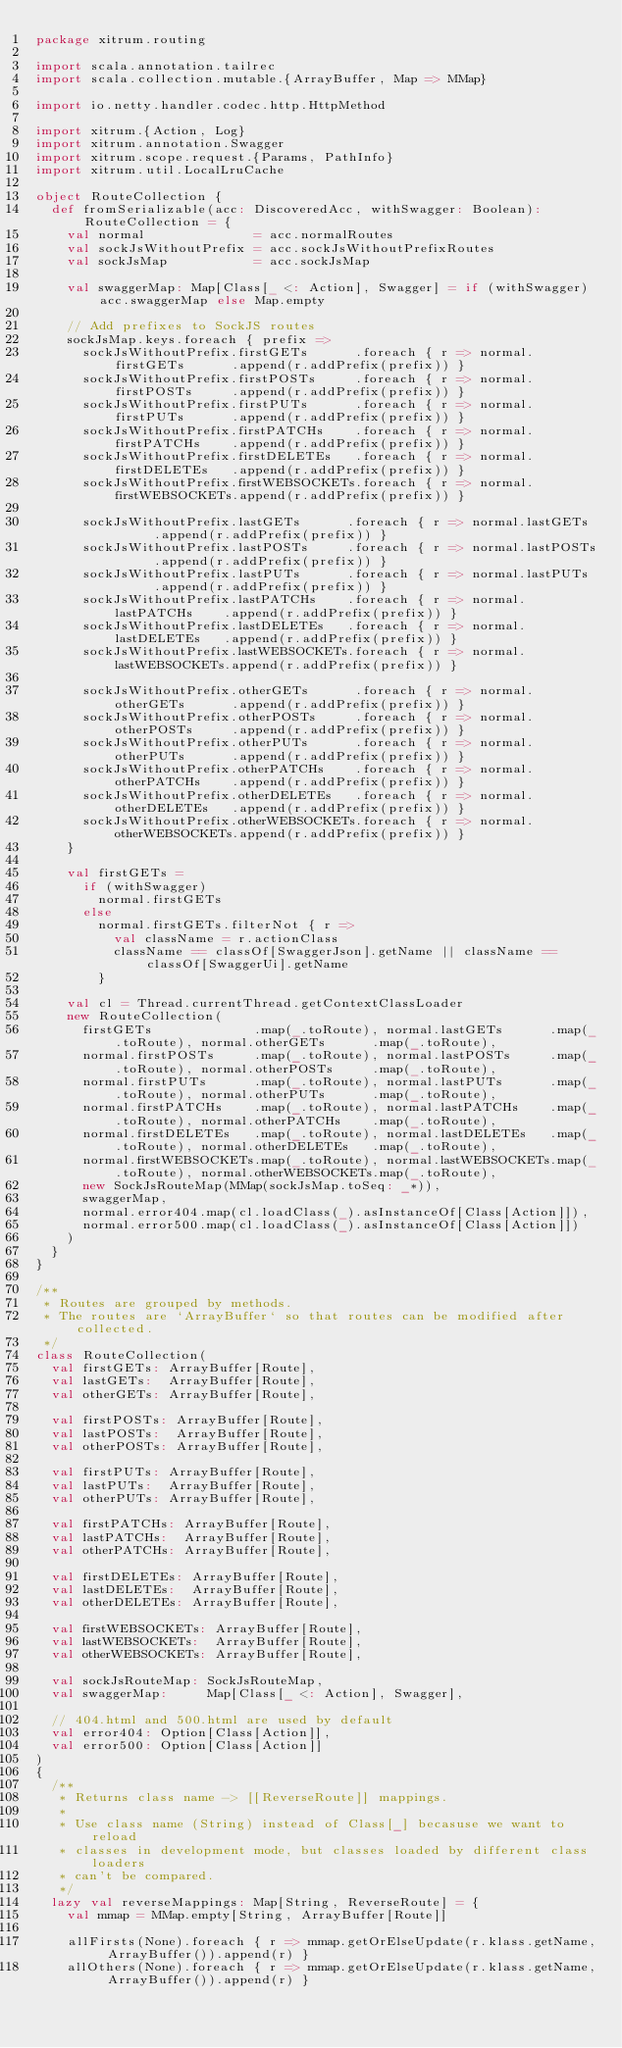Convert code to text. <code><loc_0><loc_0><loc_500><loc_500><_Scala_>package xitrum.routing

import scala.annotation.tailrec
import scala.collection.mutable.{ArrayBuffer, Map => MMap}

import io.netty.handler.codec.http.HttpMethod

import xitrum.{Action, Log}
import xitrum.annotation.Swagger
import xitrum.scope.request.{Params, PathInfo}
import xitrum.util.LocalLruCache

object RouteCollection {
  def fromSerializable(acc: DiscoveredAcc, withSwagger: Boolean): RouteCollection = {
    val normal              = acc.normalRoutes
    val sockJsWithoutPrefix = acc.sockJsWithoutPrefixRoutes
    val sockJsMap           = acc.sockJsMap

    val swaggerMap: Map[Class[_ <: Action], Swagger] = if (withSwagger) acc.swaggerMap else Map.empty

    // Add prefixes to SockJS routes
    sockJsMap.keys.foreach { prefix =>
      sockJsWithoutPrefix.firstGETs      .foreach { r => normal.firstGETs      .append(r.addPrefix(prefix)) }
      sockJsWithoutPrefix.firstPOSTs     .foreach { r => normal.firstPOSTs     .append(r.addPrefix(prefix)) }
      sockJsWithoutPrefix.firstPUTs      .foreach { r => normal.firstPUTs      .append(r.addPrefix(prefix)) }
      sockJsWithoutPrefix.firstPATCHs    .foreach { r => normal.firstPATCHs    .append(r.addPrefix(prefix)) }
      sockJsWithoutPrefix.firstDELETEs   .foreach { r => normal.firstDELETEs   .append(r.addPrefix(prefix)) }
      sockJsWithoutPrefix.firstWEBSOCKETs.foreach { r => normal.firstWEBSOCKETs.append(r.addPrefix(prefix)) }

      sockJsWithoutPrefix.lastGETs      .foreach { r => normal.lastGETs      .append(r.addPrefix(prefix)) }
      sockJsWithoutPrefix.lastPOSTs     .foreach { r => normal.lastPOSTs     .append(r.addPrefix(prefix)) }
      sockJsWithoutPrefix.lastPUTs      .foreach { r => normal.lastPUTs      .append(r.addPrefix(prefix)) }
      sockJsWithoutPrefix.lastPATCHs    .foreach { r => normal.lastPATCHs    .append(r.addPrefix(prefix)) }
      sockJsWithoutPrefix.lastDELETEs   .foreach { r => normal.lastDELETEs   .append(r.addPrefix(prefix)) }
      sockJsWithoutPrefix.lastWEBSOCKETs.foreach { r => normal.lastWEBSOCKETs.append(r.addPrefix(prefix)) }

      sockJsWithoutPrefix.otherGETs      .foreach { r => normal.otherGETs      .append(r.addPrefix(prefix)) }
      sockJsWithoutPrefix.otherPOSTs     .foreach { r => normal.otherPOSTs     .append(r.addPrefix(prefix)) }
      sockJsWithoutPrefix.otherPUTs      .foreach { r => normal.otherPUTs      .append(r.addPrefix(prefix)) }
      sockJsWithoutPrefix.otherPATCHs    .foreach { r => normal.otherPATCHs    .append(r.addPrefix(prefix)) }
      sockJsWithoutPrefix.otherDELETEs   .foreach { r => normal.otherDELETEs   .append(r.addPrefix(prefix)) }
      sockJsWithoutPrefix.otherWEBSOCKETs.foreach { r => normal.otherWEBSOCKETs.append(r.addPrefix(prefix)) }
    }

    val firstGETs =
      if (withSwagger)
        normal.firstGETs
      else
        normal.firstGETs.filterNot { r =>
          val className = r.actionClass
          className == classOf[SwaggerJson].getName || className == classOf[SwaggerUi].getName
        }

    val cl = Thread.currentThread.getContextClassLoader
    new RouteCollection(
      firstGETs             .map(_.toRoute), normal.lastGETs      .map(_.toRoute), normal.otherGETs      .map(_.toRoute),
      normal.firstPOSTs     .map(_.toRoute), normal.lastPOSTs     .map(_.toRoute), normal.otherPOSTs     .map(_.toRoute),
      normal.firstPUTs      .map(_.toRoute), normal.lastPUTs      .map(_.toRoute), normal.otherPUTs      .map(_.toRoute),
      normal.firstPATCHs    .map(_.toRoute), normal.lastPATCHs    .map(_.toRoute), normal.otherPATCHs    .map(_.toRoute),
      normal.firstDELETEs   .map(_.toRoute), normal.lastDELETEs   .map(_.toRoute), normal.otherDELETEs   .map(_.toRoute),
      normal.firstWEBSOCKETs.map(_.toRoute), normal.lastWEBSOCKETs.map(_.toRoute), normal.otherWEBSOCKETs.map(_.toRoute),
      new SockJsRouteMap(MMap(sockJsMap.toSeq: _*)),
      swaggerMap,
      normal.error404.map(cl.loadClass(_).asInstanceOf[Class[Action]]),
      normal.error500.map(cl.loadClass(_).asInstanceOf[Class[Action]])
    )
  }
}

/**
 * Routes are grouped by methods.
 * The routes are `ArrayBuffer` so that routes can be modified after collected.
 */
class RouteCollection(
  val firstGETs: ArrayBuffer[Route],
  val lastGETs:  ArrayBuffer[Route],
  val otherGETs: ArrayBuffer[Route],

  val firstPOSTs: ArrayBuffer[Route],
  val lastPOSTs:  ArrayBuffer[Route],
  val otherPOSTs: ArrayBuffer[Route],

  val firstPUTs: ArrayBuffer[Route],
  val lastPUTs:  ArrayBuffer[Route],
  val otherPUTs: ArrayBuffer[Route],

  val firstPATCHs: ArrayBuffer[Route],
  val lastPATCHs:  ArrayBuffer[Route],
  val otherPATCHs: ArrayBuffer[Route],

  val firstDELETEs: ArrayBuffer[Route],
  val lastDELETEs:  ArrayBuffer[Route],
  val otherDELETEs: ArrayBuffer[Route],

  val firstWEBSOCKETs: ArrayBuffer[Route],
  val lastWEBSOCKETs:  ArrayBuffer[Route],
  val otherWEBSOCKETs: ArrayBuffer[Route],

  val sockJsRouteMap: SockJsRouteMap,
  val swaggerMap:     Map[Class[_ <: Action], Swagger],

  // 404.html and 500.html are used by default
  val error404: Option[Class[Action]],
  val error500: Option[Class[Action]]
)
{
  /**
   * Returns class name -> [[ReverseRoute]] mappings.
   *
   * Use class name (String) instead of Class[_] becasuse we want to reload
   * classes in development mode, but classes loaded by different class loaders
   * can't be compared.
   */
  lazy val reverseMappings: Map[String, ReverseRoute] = {
    val mmap = MMap.empty[String, ArrayBuffer[Route]]

    allFirsts(None).foreach { r => mmap.getOrElseUpdate(r.klass.getName, ArrayBuffer()).append(r) }
    allOthers(None).foreach { r => mmap.getOrElseUpdate(r.klass.getName, ArrayBuffer()).append(r) }</code> 